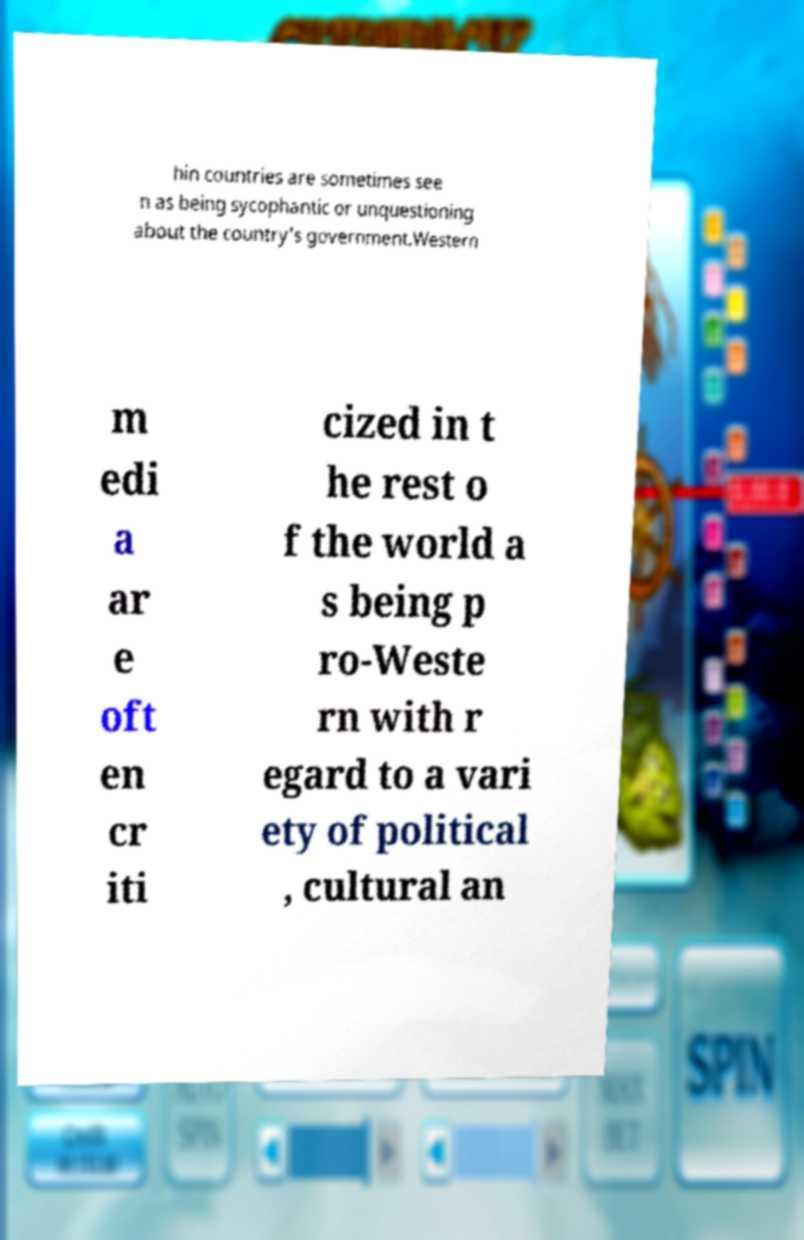Can you accurately transcribe the text from the provided image for me? hin countries are sometimes see n as being sycophantic or unquestioning about the country's government.Western m edi a ar e oft en cr iti cized in t he rest o f the world a s being p ro-Weste rn with r egard to a vari ety of political , cultural an 